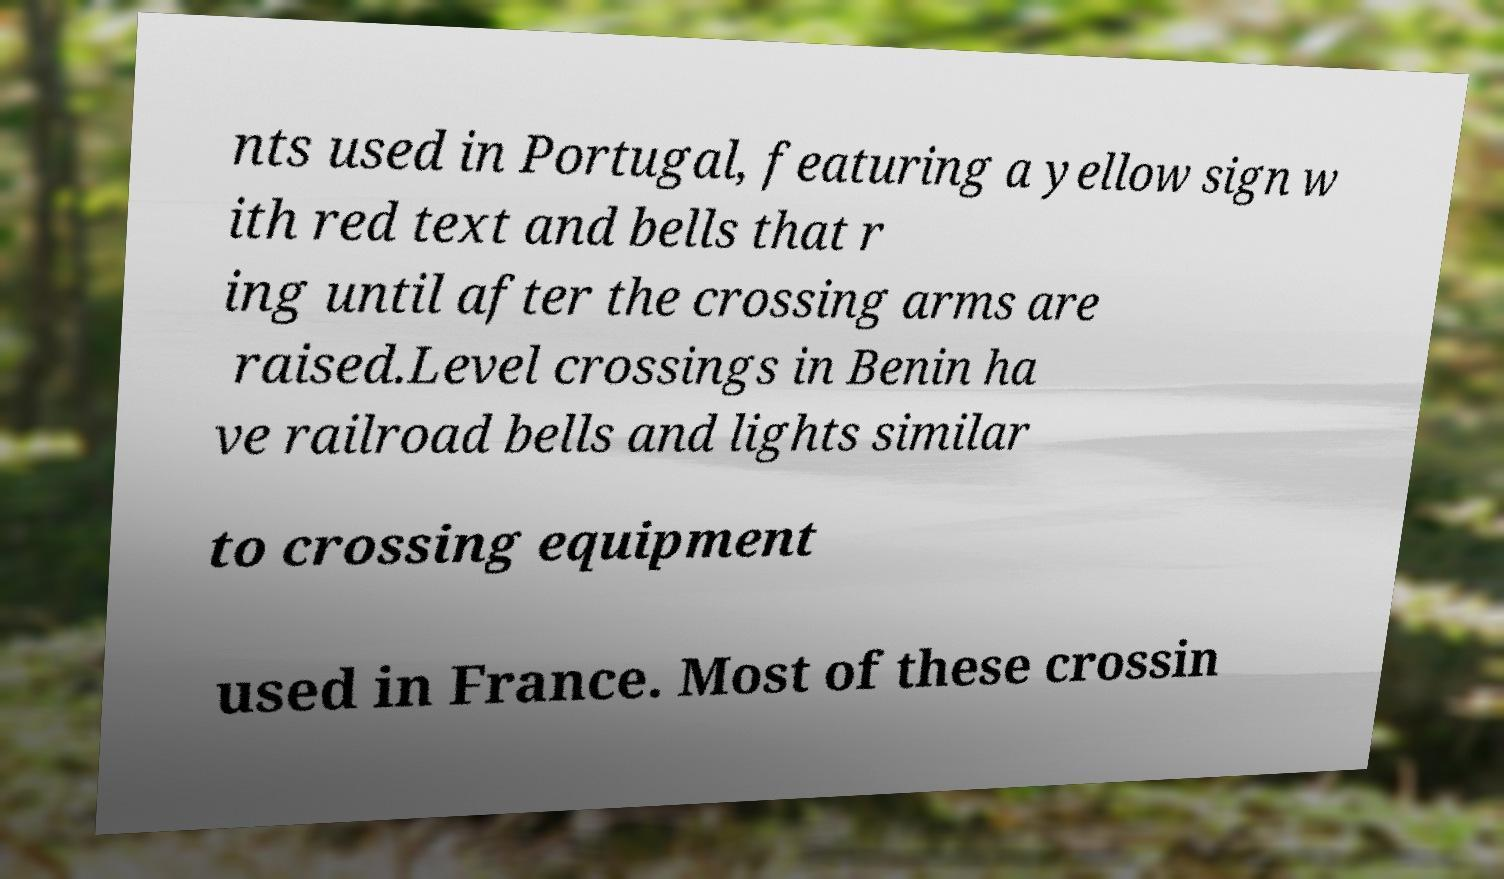Can you accurately transcribe the text from the provided image for me? nts used in Portugal, featuring a yellow sign w ith red text and bells that r ing until after the crossing arms are raised.Level crossings in Benin ha ve railroad bells and lights similar to crossing equipment used in France. Most of these crossin 